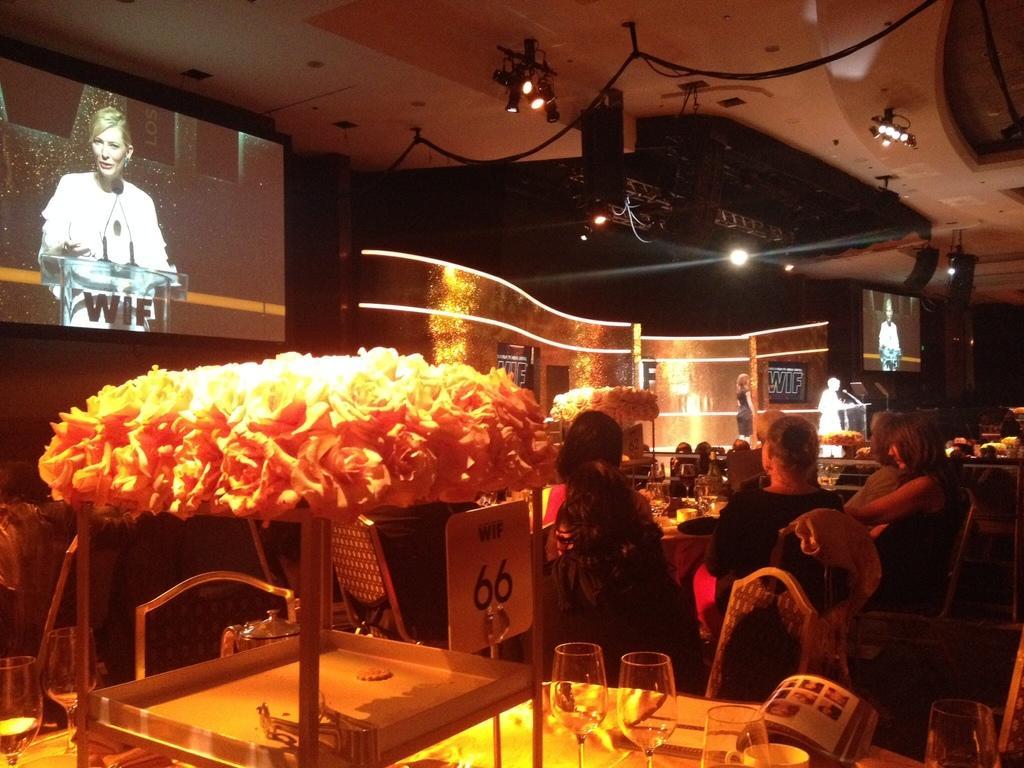Describe this image in one or two sentences. In this picture we can see some people are sitting on chairs and on the left side of the people there is a table and on the table there are glades, book, board with a stand, flowers and an object. In front of the people there are projector screens and other objects. On the screen we can see a woman is standing behind the podium and on the podium there are microphones. At the top there are lights and cables. 